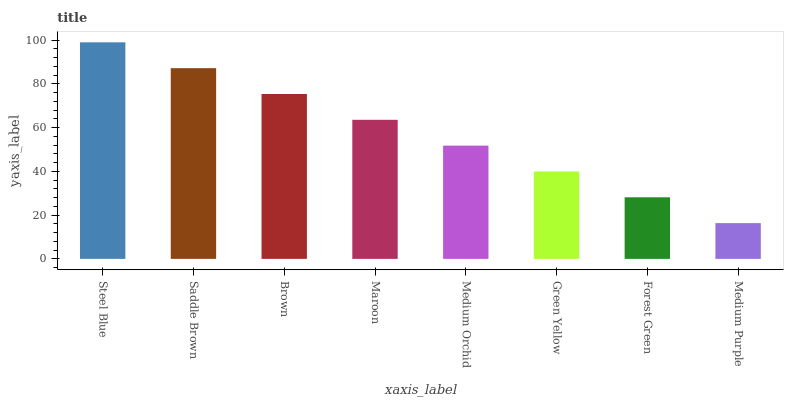Is Medium Purple the minimum?
Answer yes or no. Yes. Is Steel Blue the maximum?
Answer yes or no. Yes. Is Saddle Brown the minimum?
Answer yes or no. No. Is Saddle Brown the maximum?
Answer yes or no. No. Is Steel Blue greater than Saddle Brown?
Answer yes or no. Yes. Is Saddle Brown less than Steel Blue?
Answer yes or no. Yes. Is Saddle Brown greater than Steel Blue?
Answer yes or no. No. Is Steel Blue less than Saddle Brown?
Answer yes or no. No. Is Maroon the high median?
Answer yes or no. Yes. Is Medium Orchid the low median?
Answer yes or no. Yes. Is Medium Orchid the high median?
Answer yes or no. No. Is Maroon the low median?
Answer yes or no. No. 